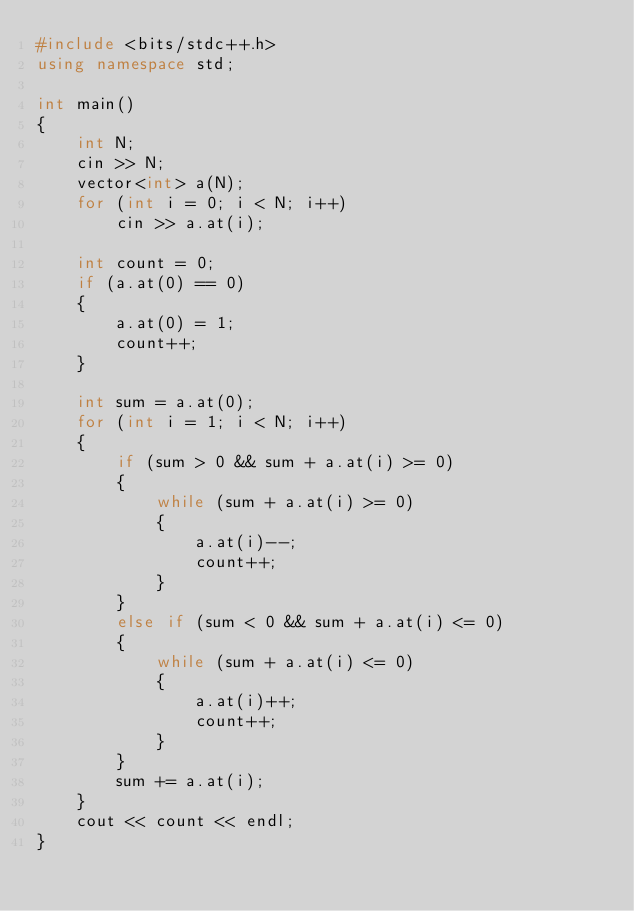Convert code to text. <code><loc_0><loc_0><loc_500><loc_500><_C++_>#include <bits/stdc++.h>
using namespace std;

int main()
{
    int N;
    cin >> N;
    vector<int> a(N);
    for (int i = 0; i < N; i++)
        cin >> a.at(i);

    int count = 0;
    if (a.at(0) == 0)
    {
        a.at(0) = 1;
        count++;
    }

    int sum = a.at(0);
    for (int i = 1; i < N; i++)
    {
        if (sum > 0 && sum + a.at(i) >= 0)
        {
            while (sum + a.at(i) >= 0)
            {
                a.at(i)--;
                count++;
            }
        }
        else if (sum < 0 && sum + a.at(i) <= 0)
        {
            while (sum + a.at(i) <= 0)
            {
                a.at(i)++;
                count++;
            }
        }
        sum += a.at(i);
    }
    cout << count << endl;
}</code> 